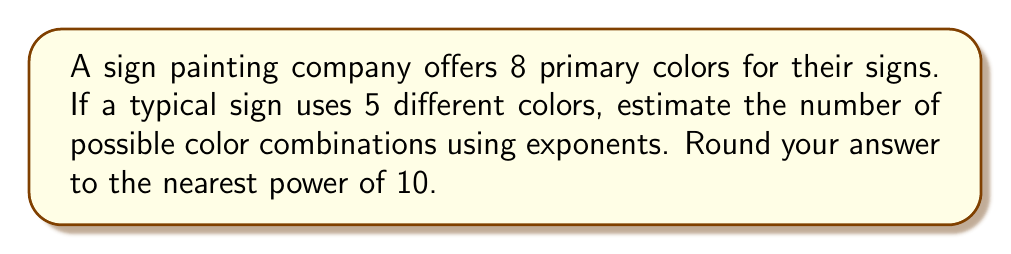Teach me how to tackle this problem. Let's approach this step-by-step:

1) We have 8 colors to choose from, and we need to select 5 of them for each sign.

2) This is a combination problem, as the order of colors doesn't matter (e.g., red-blue-green is the same as blue-green-red on a sign).

3) The formula for combinations is:

   $$C(n,r) = \frac{n!}{r!(n-r)!}$$

   Where $n$ is the total number of items to choose from, and $r$ is the number of items being chosen.

4) In this case, $n = 8$ and $r = 5$. Let's calculate:

   $$C(8,5) = \frac{8!}{5!(8-5)!} = \frac{8!}{5!3!}$$

5) Expanding this:

   $$\frac{8 \cdot 7 \cdot 6 \cdot 5!}{5! \cdot 3 \cdot 2 \cdot 1} = \frac{8 \cdot 7 \cdot 6}{3 \cdot 2 \cdot 1} = \frac{336}{6} = 56$$

6) The exact number of combinations is 56.

7) To express this as a power of 10, we need to find the closest power of 10 to 56.

   $10^1 = 10$ (too small)
   $10^2 = 100$ (closest)
   $10^3 = 1000$ (too large)

Therefore, rounding to the nearest power of 10, we get $10^2 = 100$.
Answer: $10^2$ or 100 